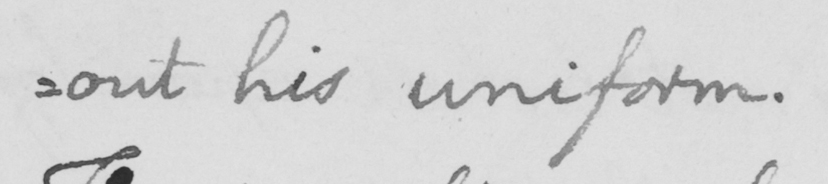What is written in this line of handwriting? :out his uniform. 